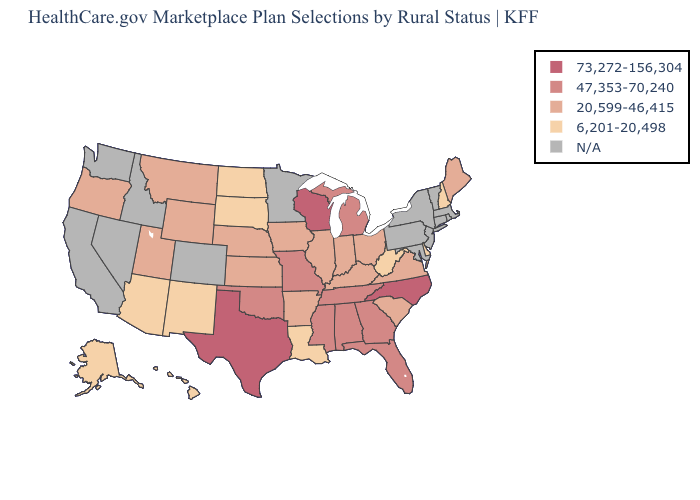Does the first symbol in the legend represent the smallest category?
Be succinct. No. Does Ohio have the highest value in the MidWest?
Concise answer only. No. Name the states that have a value in the range 20,599-46,415?
Answer briefly. Arkansas, Illinois, Indiana, Iowa, Kansas, Kentucky, Maine, Montana, Nebraska, Ohio, Oregon, South Carolina, Utah, Virginia, Wyoming. Which states have the lowest value in the South?
Be succinct. Delaware, Louisiana, West Virginia. What is the value of South Dakota?
Be succinct. 6,201-20,498. What is the value of Kentucky?
Answer briefly. 20,599-46,415. Which states hav the highest value in the West?
Give a very brief answer. Montana, Oregon, Utah, Wyoming. Name the states that have a value in the range 20,599-46,415?
Answer briefly. Arkansas, Illinois, Indiana, Iowa, Kansas, Kentucky, Maine, Montana, Nebraska, Ohio, Oregon, South Carolina, Utah, Virginia, Wyoming. Which states hav the highest value in the MidWest?
Concise answer only. Wisconsin. What is the value of Arizona?
Short answer required. 6,201-20,498. Does Alaska have the lowest value in the West?
Short answer required. Yes. Name the states that have a value in the range 6,201-20,498?
Quick response, please. Alaska, Arizona, Delaware, Hawaii, Louisiana, New Hampshire, New Mexico, North Dakota, South Dakota, West Virginia. Name the states that have a value in the range 6,201-20,498?
Keep it brief. Alaska, Arizona, Delaware, Hawaii, Louisiana, New Hampshire, New Mexico, North Dakota, South Dakota, West Virginia. 